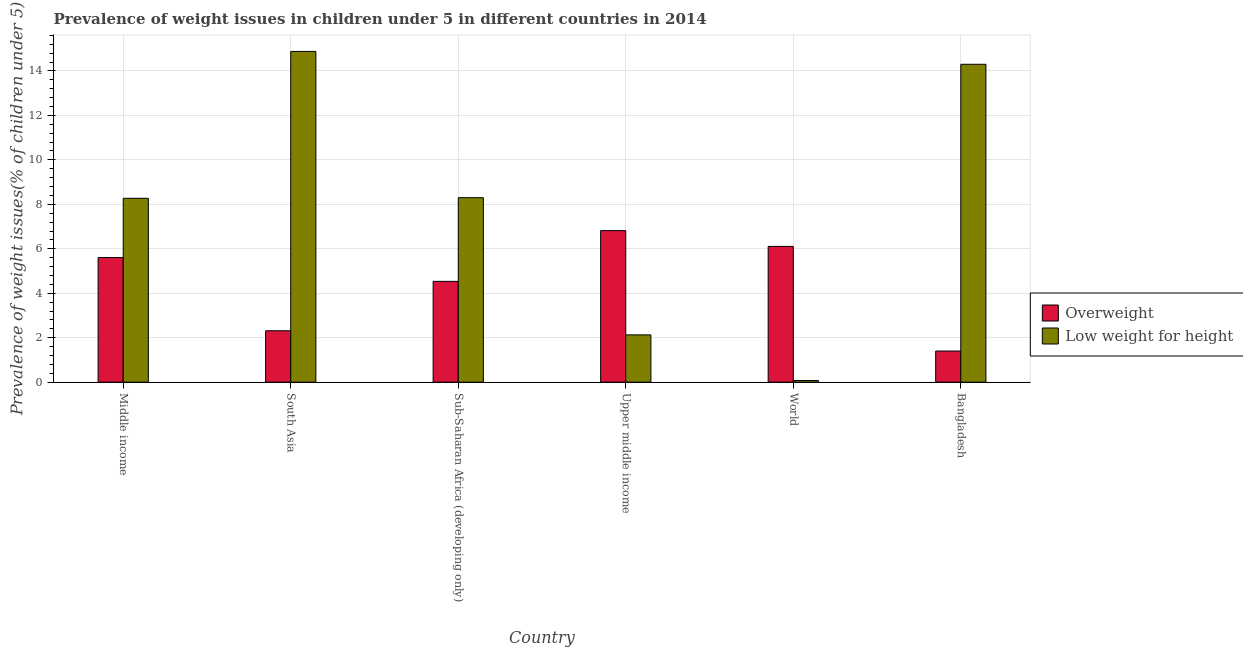Are the number of bars per tick equal to the number of legend labels?
Offer a very short reply. Yes. How many bars are there on the 5th tick from the left?
Offer a very short reply. 2. What is the label of the 3rd group of bars from the left?
Keep it short and to the point. Sub-Saharan Africa (developing only). In how many cases, is the number of bars for a given country not equal to the number of legend labels?
Keep it short and to the point. 0. What is the percentage of underweight children in Upper middle income?
Make the answer very short. 2.13. Across all countries, what is the maximum percentage of overweight children?
Make the answer very short. 6.82. Across all countries, what is the minimum percentage of underweight children?
Offer a very short reply. 0.08. In which country was the percentage of underweight children maximum?
Make the answer very short. South Asia. In which country was the percentage of underweight children minimum?
Your response must be concise. World. What is the total percentage of overweight children in the graph?
Your response must be concise. 26.77. What is the difference between the percentage of overweight children in Bangladesh and that in World?
Keep it short and to the point. -4.71. What is the difference between the percentage of overweight children in Middle income and the percentage of underweight children in South Asia?
Keep it short and to the point. -9.27. What is the average percentage of underweight children per country?
Offer a terse response. 7.99. What is the difference between the percentage of overweight children and percentage of underweight children in Sub-Saharan Africa (developing only)?
Your response must be concise. -3.76. In how many countries, is the percentage of overweight children greater than 11.6 %?
Make the answer very short. 0. What is the ratio of the percentage of underweight children in South Asia to that in World?
Your answer should be compact. 198.33. What is the difference between the highest and the second highest percentage of underweight children?
Ensure brevity in your answer.  0.58. What is the difference between the highest and the lowest percentage of underweight children?
Provide a succinct answer. 14.8. What does the 2nd bar from the left in World represents?
Your response must be concise. Low weight for height. What does the 1st bar from the right in World represents?
Give a very brief answer. Low weight for height. How many bars are there?
Your answer should be compact. 12. How many countries are there in the graph?
Ensure brevity in your answer.  6. Are the values on the major ticks of Y-axis written in scientific E-notation?
Provide a short and direct response. No. How many legend labels are there?
Offer a very short reply. 2. What is the title of the graph?
Your response must be concise. Prevalence of weight issues in children under 5 in different countries in 2014. What is the label or title of the X-axis?
Offer a very short reply. Country. What is the label or title of the Y-axis?
Provide a succinct answer. Prevalence of weight issues(% of children under 5). What is the Prevalence of weight issues(% of children under 5) of Overweight in Middle income?
Your answer should be very brief. 5.6. What is the Prevalence of weight issues(% of children under 5) of Low weight for height in Middle income?
Your response must be concise. 8.27. What is the Prevalence of weight issues(% of children under 5) of Overweight in South Asia?
Provide a succinct answer. 2.31. What is the Prevalence of weight issues(% of children under 5) of Low weight for height in South Asia?
Provide a short and direct response. 14.88. What is the Prevalence of weight issues(% of children under 5) of Overweight in Sub-Saharan Africa (developing only)?
Ensure brevity in your answer.  4.53. What is the Prevalence of weight issues(% of children under 5) in Low weight for height in Sub-Saharan Africa (developing only)?
Ensure brevity in your answer.  8.3. What is the Prevalence of weight issues(% of children under 5) in Overweight in Upper middle income?
Ensure brevity in your answer.  6.82. What is the Prevalence of weight issues(% of children under 5) of Low weight for height in Upper middle income?
Your response must be concise. 2.13. What is the Prevalence of weight issues(% of children under 5) in Overweight in World?
Provide a short and direct response. 6.11. What is the Prevalence of weight issues(% of children under 5) in Low weight for height in World?
Make the answer very short. 0.08. What is the Prevalence of weight issues(% of children under 5) of Overweight in Bangladesh?
Offer a very short reply. 1.4. What is the Prevalence of weight issues(% of children under 5) of Low weight for height in Bangladesh?
Your answer should be compact. 14.3. Across all countries, what is the maximum Prevalence of weight issues(% of children under 5) in Overweight?
Offer a very short reply. 6.82. Across all countries, what is the maximum Prevalence of weight issues(% of children under 5) in Low weight for height?
Your answer should be compact. 14.88. Across all countries, what is the minimum Prevalence of weight issues(% of children under 5) in Overweight?
Your answer should be compact. 1.4. Across all countries, what is the minimum Prevalence of weight issues(% of children under 5) in Low weight for height?
Offer a very short reply. 0.08. What is the total Prevalence of weight issues(% of children under 5) in Overweight in the graph?
Make the answer very short. 26.77. What is the total Prevalence of weight issues(% of children under 5) in Low weight for height in the graph?
Your answer should be compact. 47.95. What is the difference between the Prevalence of weight issues(% of children under 5) in Overweight in Middle income and that in South Asia?
Provide a succinct answer. 3.29. What is the difference between the Prevalence of weight issues(% of children under 5) of Low weight for height in Middle income and that in South Asia?
Provide a short and direct response. -6.61. What is the difference between the Prevalence of weight issues(% of children under 5) in Overweight in Middle income and that in Sub-Saharan Africa (developing only)?
Keep it short and to the point. 1.07. What is the difference between the Prevalence of weight issues(% of children under 5) of Low weight for height in Middle income and that in Sub-Saharan Africa (developing only)?
Your response must be concise. -0.03. What is the difference between the Prevalence of weight issues(% of children under 5) of Overweight in Middle income and that in Upper middle income?
Give a very brief answer. -1.21. What is the difference between the Prevalence of weight issues(% of children under 5) in Low weight for height in Middle income and that in Upper middle income?
Offer a very short reply. 6.15. What is the difference between the Prevalence of weight issues(% of children under 5) in Overweight in Middle income and that in World?
Give a very brief answer. -0.5. What is the difference between the Prevalence of weight issues(% of children under 5) in Low weight for height in Middle income and that in World?
Keep it short and to the point. 8.2. What is the difference between the Prevalence of weight issues(% of children under 5) of Overweight in Middle income and that in Bangladesh?
Give a very brief answer. 4.2. What is the difference between the Prevalence of weight issues(% of children under 5) of Low weight for height in Middle income and that in Bangladesh?
Make the answer very short. -6.03. What is the difference between the Prevalence of weight issues(% of children under 5) of Overweight in South Asia and that in Sub-Saharan Africa (developing only)?
Offer a very short reply. -2.22. What is the difference between the Prevalence of weight issues(% of children under 5) in Low weight for height in South Asia and that in Sub-Saharan Africa (developing only)?
Provide a short and direct response. 6.58. What is the difference between the Prevalence of weight issues(% of children under 5) in Overweight in South Asia and that in Upper middle income?
Give a very brief answer. -4.51. What is the difference between the Prevalence of weight issues(% of children under 5) in Low weight for height in South Asia and that in Upper middle income?
Keep it short and to the point. 12.75. What is the difference between the Prevalence of weight issues(% of children under 5) of Overweight in South Asia and that in World?
Give a very brief answer. -3.8. What is the difference between the Prevalence of weight issues(% of children under 5) in Low weight for height in South Asia and that in World?
Offer a very short reply. 14.8. What is the difference between the Prevalence of weight issues(% of children under 5) of Overweight in South Asia and that in Bangladesh?
Your answer should be very brief. 0.91. What is the difference between the Prevalence of weight issues(% of children under 5) in Low weight for height in South Asia and that in Bangladesh?
Your answer should be compact. 0.58. What is the difference between the Prevalence of weight issues(% of children under 5) in Overweight in Sub-Saharan Africa (developing only) and that in Upper middle income?
Provide a succinct answer. -2.28. What is the difference between the Prevalence of weight issues(% of children under 5) in Low weight for height in Sub-Saharan Africa (developing only) and that in Upper middle income?
Provide a succinct answer. 6.17. What is the difference between the Prevalence of weight issues(% of children under 5) in Overweight in Sub-Saharan Africa (developing only) and that in World?
Make the answer very short. -1.57. What is the difference between the Prevalence of weight issues(% of children under 5) in Low weight for height in Sub-Saharan Africa (developing only) and that in World?
Offer a very short reply. 8.22. What is the difference between the Prevalence of weight issues(% of children under 5) in Overweight in Sub-Saharan Africa (developing only) and that in Bangladesh?
Give a very brief answer. 3.13. What is the difference between the Prevalence of weight issues(% of children under 5) in Low weight for height in Sub-Saharan Africa (developing only) and that in Bangladesh?
Provide a succinct answer. -6. What is the difference between the Prevalence of weight issues(% of children under 5) in Overweight in Upper middle income and that in World?
Your answer should be very brief. 0.71. What is the difference between the Prevalence of weight issues(% of children under 5) of Low weight for height in Upper middle income and that in World?
Provide a short and direct response. 2.05. What is the difference between the Prevalence of weight issues(% of children under 5) of Overweight in Upper middle income and that in Bangladesh?
Your answer should be compact. 5.42. What is the difference between the Prevalence of weight issues(% of children under 5) of Low weight for height in Upper middle income and that in Bangladesh?
Offer a very short reply. -12.17. What is the difference between the Prevalence of weight issues(% of children under 5) of Overweight in World and that in Bangladesh?
Ensure brevity in your answer.  4.71. What is the difference between the Prevalence of weight issues(% of children under 5) in Low weight for height in World and that in Bangladesh?
Provide a short and direct response. -14.22. What is the difference between the Prevalence of weight issues(% of children under 5) of Overweight in Middle income and the Prevalence of weight issues(% of children under 5) of Low weight for height in South Asia?
Offer a terse response. -9.27. What is the difference between the Prevalence of weight issues(% of children under 5) of Overweight in Middle income and the Prevalence of weight issues(% of children under 5) of Low weight for height in Sub-Saharan Africa (developing only)?
Ensure brevity in your answer.  -2.69. What is the difference between the Prevalence of weight issues(% of children under 5) in Overweight in Middle income and the Prevalence of weight issues(% of children under 5) in Low weight for height in Upper middle income?
Make the answer very short. 3.48. What is the difference between the Prevalence of weight issues(% of children under 5) of Overweight in Middle income and the Prevalence of weight issues(% of children under 5) of Low weight for height in World?
Offer a very short reply. 5.53. What is the difference between the Prevalence of weight issues(% of children under 5) of Overweight in Middle income and the Prevalence of weight issues(% of children under 5) of Low weight for height in Bangladesh?
Provide a short and direct response. -8.7. What is the difference between the Prevalence of weight issues(% of children under 5) in Overweight in South Asia and the Prevalence of weight issues(% of children under 5) in Low weight for height in Sub-Saharan Africa (developing only)?
Offer a terse response. -5.99. What is the difference between the Prevalence of weight issues(% of children under 5) of Overweight in South Asia and the Prevalence of weight issues(% of children under 5) of Low weight for height in Upper middle income?
Your answer should be compact. 0.19. What is the difference between the Prevalence of weight issues(% of children under 5) of Overweight in South Asia and the Prevalence of weight issues(% of children under 5) of Low weight for height in World?
Make the answer very short. 2.24. What is the difference between the Prevalence of weight issues(% of children under 5) of Overweight in South Asia and the Prevalence of weight issues(% of children under 5) of Low weight for height in Bangladesh?
Your response must be concise. -11.99. What is the difference between the Prevalence of weight issues(% of children under 5) of Overweight in Sub-Saharan Africa (developing only) and the Prevalence of weight issues(% of children under 5) of Low weight for height in Upper middle income?
Ensure brevity in your answer.  2.41. What is the difference between the Prevalence of weight issues(% of children under 5) of Overweight in Sub-Saharan Africa (developing only) and the Prevalence of weight issues(% of children under 5) of Low weight for height in World?
Provide a short and direct response. 4.46. What is the difference between the Prevalence of weight issues(% of children under 5) of Overweight in Sub-Saharan Africa (developing only) and the Prevalence of weight issues(% of children under 5) of Low weight for height in Bangladesh?
Your response must be concise. -9.77. What is the difference between the Prevalence of weight issues(% of children under 5) of Overweight in Upper middle income and the Prevalence of weight issues(% of children under 5) of Low weight for height in World?
Offer a terse response. 6.74. What is the difference between the Prevalence of weight issues(% of children under 5) in Overweight in Upper middle income and the Prevalence of weight issues(% of children under 5) in Low weight for height in Bangladesh?
Your response must be concise. -7.48. What is the difference between the Prevalence of weight issues(% of children under 5) of Overweight in World and the Prevalence of weight issues(% of children under 5) of Low weight for height in Bangladesh?
Make the answer very short. -8.19. What is the average Prevalence of weight issues(% of children under 5) of Overweight per country?
Offer a terse response. 4.46. What is the average Prevalence of weight issues(% of children under 5) of Low weight for height per country?
Make the answer very short. 7.99. What is the difference between the Prevalence of weight issues(% of children under 5) in Overweight and Prevalence of weight issues(% of children under 5) in Low weight for height in Middle income?
Provide a succinct answer. -2.67. What is the difference between the Prevalence of weight issues(% of children under 5) in Overweight and Prevalence of weight issues(% of children under 5) in Low weight for height in South Asia?
Ensure brevity in your answer.  -12.57. What is the difference between the Prevalence of weight issues(% of children under 5) of Overweight and Prevalence of weight issues(% of children under 5) of Low weight for height in Sub-Saharan Africa (developing only)?
Provide a short and direct response. -3.76. What is the difference between the Prevalence of weight issues(% of children under 5) of Overweight and Prevalence of weight issues(% of children under 5) of Low weight for height in Upper middle income?
Keep it short and to the point. 4.69. What is the difference between the Prevalence of weight issues(% of children under 5) of Overweight and Prevalence of weight issues(% of children under 5) of Low weight for height in World?
Give a very brief answer. 6.03. What is the ratio of the Prevalence of weight issues(% of children under 5) in Overweight in Middle income to that in South Asia?
Offer a terse response. 2.42. What is the ratio of the Prevalence of weight issues(% of children under 5) of Low weight for height in Middle income to that in South Asia?
Provide a short and direct response. 0.56. What is the ratio of the Prevalence of weight issues(% of children under 5) of Overweight in Middle income to that in Sub-Saharan Africa (developing only)?
Make the answer very short. 1.24. What is the ratio of the Prevalence of weight issues(% of children under 5) of Overweight in Middle income to that in Upper middle income?
Make the answer very short. 0.82. What is the ratio of the Prevalence of weight issues(% of children under 5) of Low weight for height in Middle income to that in Upper middle income?
Give a very brief answer. 3.89. What is the ratio of the Prevalence of weight issues(% of children under 5) of Overweight in Middle income to that in World?
Make the answer very short. 0.92. What is the ratio of the Prevalence of weight issues(% of children under 5) of Low weight for height in Middle income to that in World?
Offer a very short reply. 110.26. What is the ratio of the Prevalence of weight issues(% of children under 5) of Overweight in Middle income to that in Bangladesh?
Offer a terse response. 4. What is the ratio of the Prevalence of weight issues(% of children under 5) in Low weight for height in Middle income to that in Bangladesh?
Keep it short and to the point. 0.58. What is the ratio of the Prevalence of weight issues(% of children under 5) in Overweight in South Asia to that in Sub-Saharan Africa (developing only)?
Ensure brevity in your answer.  0.51. What is the ratio of the Prevalence of weight issues(% of children under 5) in Low weight for height in South Asia to that in Sub-Saharan Africa (developing only)?
Keep it short and to the point. 1.79. What is the ratio of the Prevalence of weight issues(% of children under 5) in Overweight in South Asia to that in Upper middle income?
Offer a very short reply. 0.34. What is the ratio of the Prevalence of weight issues(% of children under 5) in Low weight for height in South Asia to that in Upper middle income?
Offer a terse response. 7. What is the ratio of the Prevalence of weight issues(% of children under 5) in Overweight in South Asia to that in World?
Keep it short and to the point. 0.38. What is the ratio of the Prevalence of weight issues(% of children under 5) in Low weight for height in South Asia to that in World?
Keep it short and to the point. 198.33. What is the ratio of the Prevalence of weight issues(% of children under 5) of Overweight in South Asia to that in Bangladesh?
Give a very brief answer. 1.65. What is the ratio of the Prevalence of weight issues(% of children under 5) of Low weight for height in South Asia to that in Bangladesh?
Provide a succinct answer. 1.04. What is the ratio of the Prevalence of weight issues(% of children under 5) in Overweight in Sub-Saharan Africa (developing only) to that in Upper middle income?
Ensure brevity in your answer.  0.67. What is the ratio of the Prevalence of weight issues(% of children under 5) in Low weight for height in Sub-Saharan Africa (developing only) to that in Upper middle income?
Offer a very short reply. 3.9. What is the ratio of the Prevalence of weight issues(% of children under 5) of Overweight in Sub-Saharan Africa (developing only) to that in World?
Keep it short and to the point. 0.74. What is the ratio of the Prevalence of weight issues(% of children under 5) of Low weight for height in Sub-Saharan Africa (developing only) to that in World?
Offer a very short reply. 110.61. What is the ratio of the Prevalence of weight issues(% of children under 5) in Overweight in Sub-Saharan Africa (developing only) to that in Bangladesh?
Keep it short and to the point. 3.24. What is the ratio of the Prevalence of weight issues(% of children under 5) in Low weight for height in Sub-Saharan Africa (developing only) to that in Bangladesh?
Your answer should be compact. 0.58. What is the ratio of the Prevalence of weight issues(% of children under 5) in Overweight in Upper middle income to that in World?
Offer a very short reply. 1.12. What is the ratio of the Prevalence of weight issues(% of children under 5) of Low weight for height in Upper middle income to that in World?
Make the answer very short. 28.35. What is the ratio of the Prevalence of weight issues(% of children under 5) of Overweight in Upper middle income to that in Bangladesh?
Your response must be concise. 4.87. What is the ratio of the Prevalence of weight issues(% of children under 5) of Low weight for height in Upper middle income to that in Bangladesh?
Your answer should be very brief. 0.15. What is the ratio of the Prevalence of weight issues(% of children under 5) of Overweight in World to that in Bangladesh?
Give a very brief answer. 4.36. What is the ratio of the Prevalence of weight issues(% of children under 5) of Low weight for height in World to that in Bangladesh?
Ensure brevity in your answer.  0.01. What is the difference between the highest and the second highest Prevalence of weight issues(% of children under 5) of Overweight?
Provide a short and direct response. 0.71. What is the difference between the highest and the second highest Prevalence of weight issues(% of children under 5) in Low weight for height?
Keep it short and to the point. 0.58. What is the difference between the highest and the lowest Prevalence of weight issues(% of children under 5) of Overweight?
Your answer should be very brief. 5.42. What is the difference between the highest and the lowest Prevalence of weight issues(% of children under 5) in Low weight for height?
Make the answer very short. 14.8. 